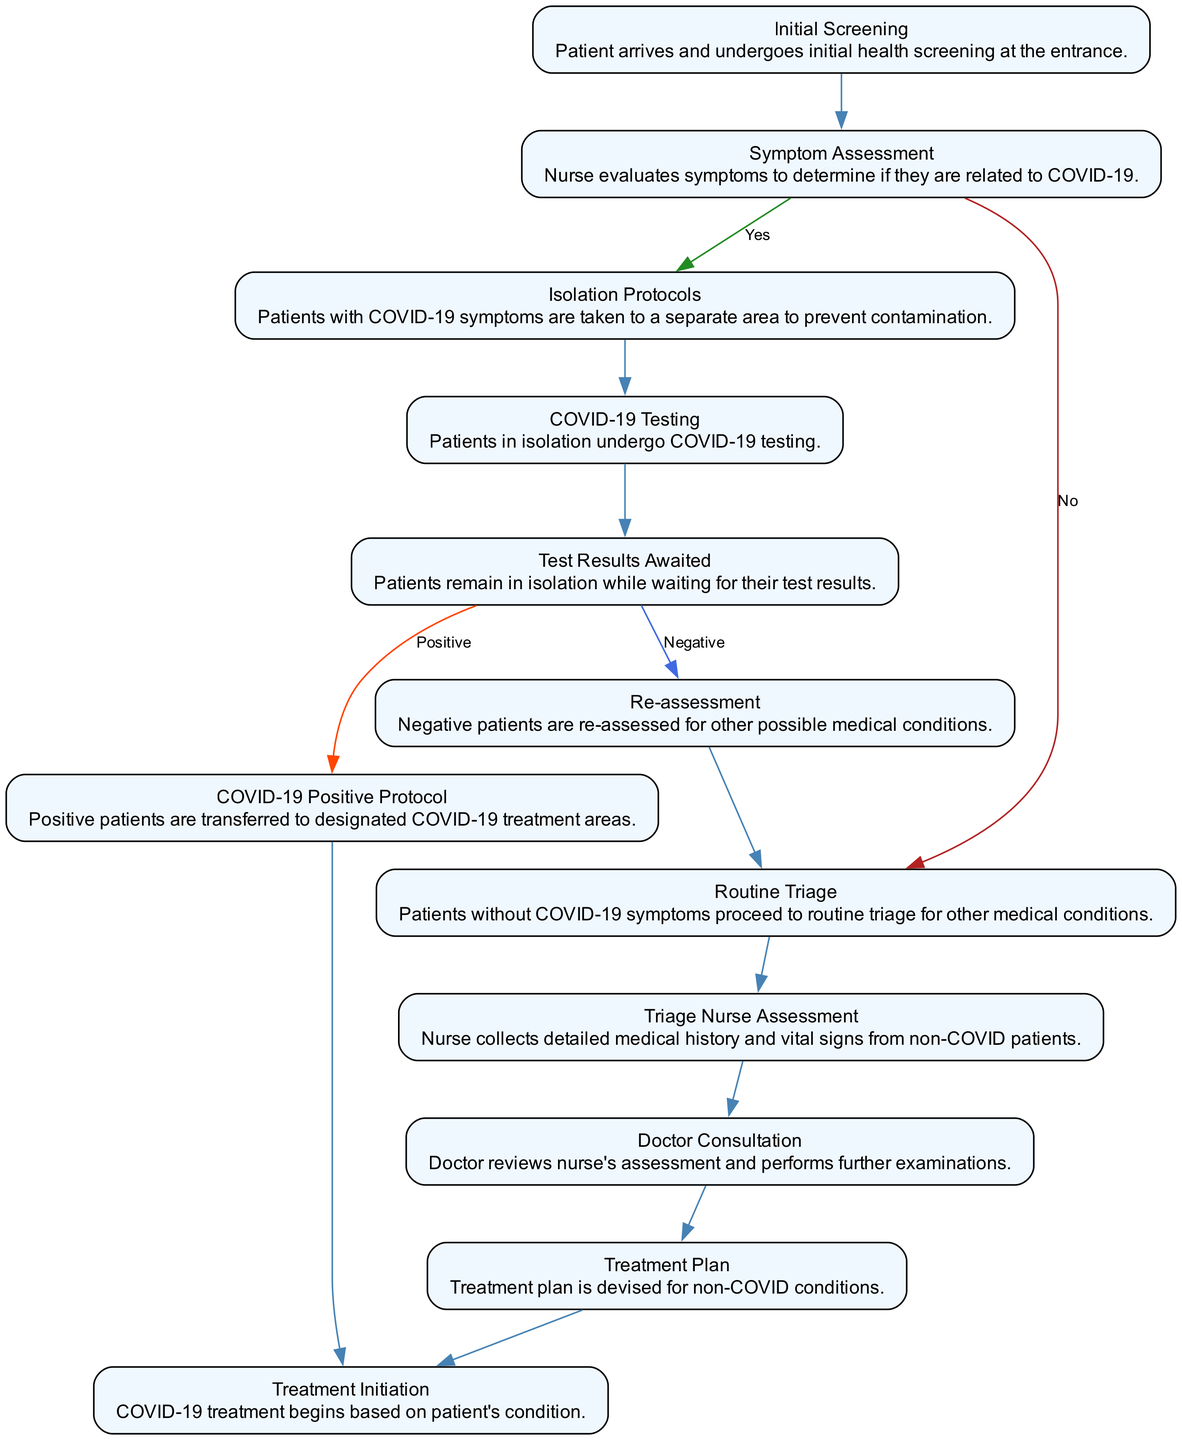What is the first step in the triage process? The diagram indicates that the first step is "Initial Screening," where patients undergo health screening upon arrival.
Answer: Initial Screening How many outputs are there from the "Symptom Assessment" step? The "Symptom Assessment" step has two outputs: "Isolation Protocols" for a positive COVID-19 assessment and "Routine Triage" for a negative result.
Answer: Two What happens if a patient receives a "COVID-19 Positive" result? If a patient is positive for COVID-19, they will follow the "COVID-19 Positive Protocol" and be transferred to treatment areas specifically for COVID-19 patients.
Answer: COVID-19 Positive Protocol Which step is reached after the "Triage Nurse Assessment"? After the "Triage Nurse Assessment," patients proceed to the "Doctor Consultation" step for further examination based on the nurse's assessment.
Answer: Doctor Consultation What is the outcome if the test results are negative? If the COVID-19 test results are negative, the patient is subjected to a "Re-assessment" to check for other potential medical conditions.
Answer: Re-assessment If a patient does not show COVID-19 symptoms, where do they go next? Patients without COVID-19 symptoms proceed directly to "Routine Triage" for evaluation of other medical conditions.
Answer: Routine Triage What is the purpose of the "Isolation Protocols" step? The "Isolation Protocols" step ensures that patients exhibiting COVID-19 symptoms are moved to a separate area to prevent contamination with other patients.
Answer: Prevent contamination How many steps are there in total in the triage process? The diagram outlines a total of 12 distinct steps involved in the patient triage process during COVID-19 precautions.
Answer: Twelve What is initiated after a "Treatment Plan" is devised for non-COVID conditions? Following the establishment of a "Treatment Plan," the next step is "Treatment Initiation," where the necessary medical treatment begins.
Answer: Treatment Initiation 